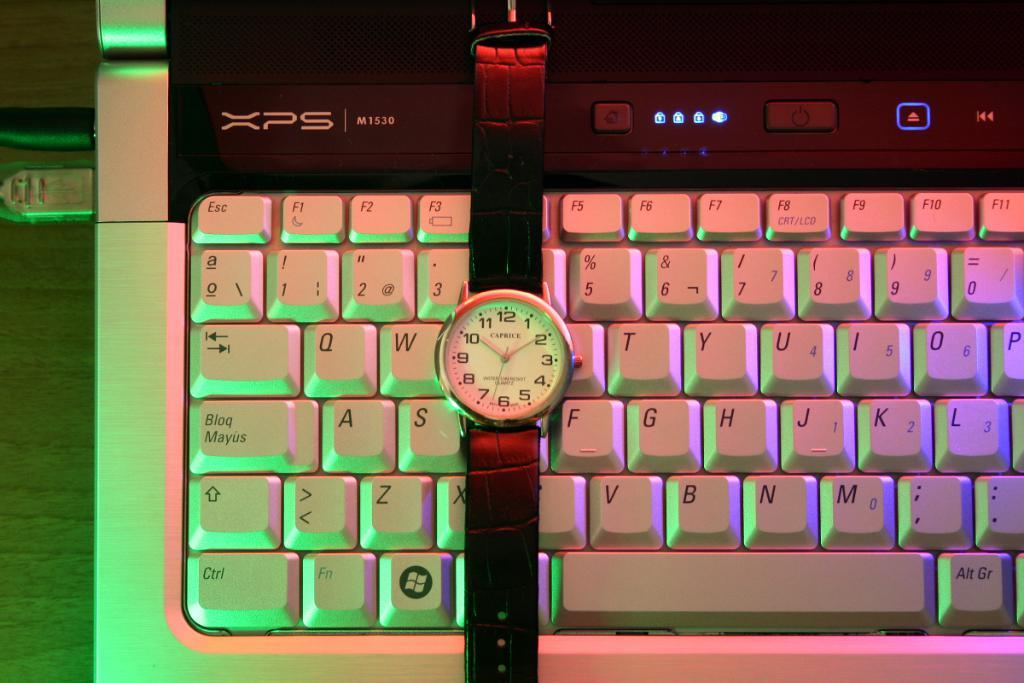<image>
Describe the image concisely. An illuminated keyboard which has XPS along the top. 